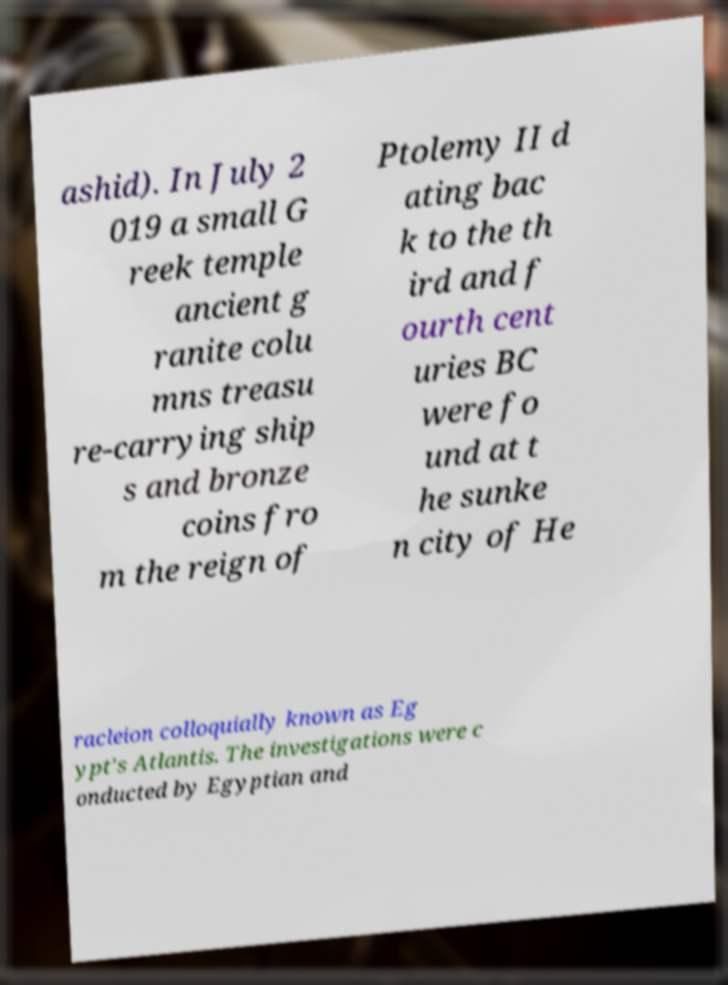Can you read and provide the text displayed in the image?This photo seems to have some interesting text. Can you extract and type it out for me? ashid). In July 2 019 a small G reek temple ancient g ranite colu mns treasu re-carrying ship s and bronze coins fro m the reign of Ptolemy II d ating bac k to the th ird and f ourth cent uries BC were fo und at t he sunke n city of He racleion colloquially known as Eg ypt's Atlantis. The investigations were c onducted by Egyptian and 